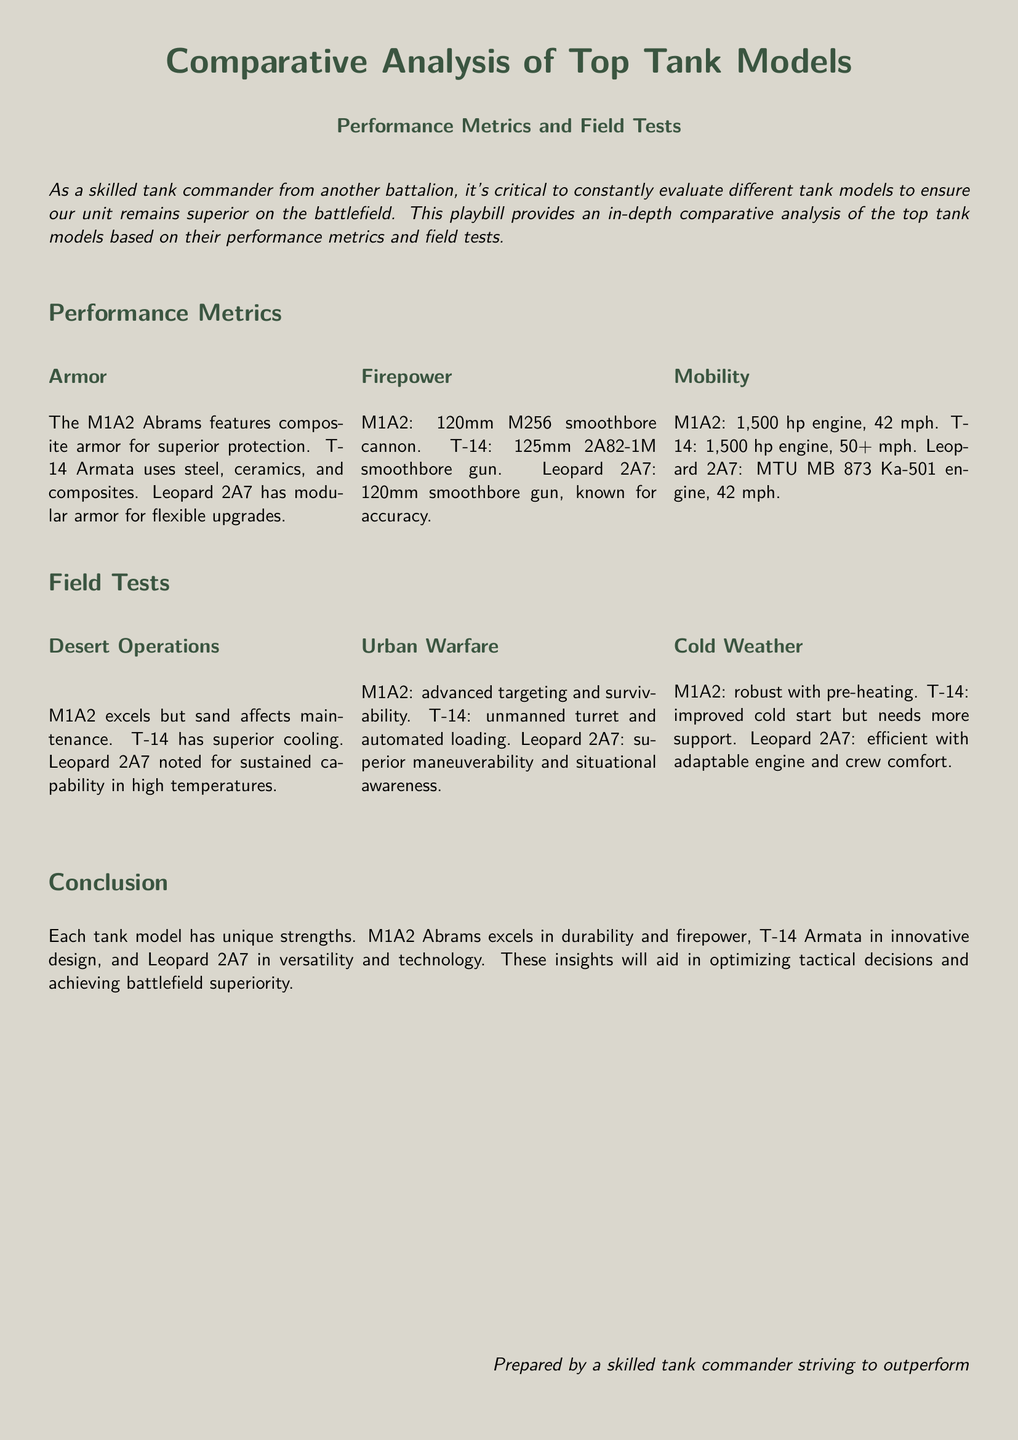What type of armor does the M1A2 Abrams feature? The document states that the M1A2 Abrams features composite armor for superior protection.
Answer: Composite armor What is the maximum speed of the T-14 Armata? According to the document, the T-14 Armata has a speed of 50+ mph.
Answer: 50+ mph Which tank model is noted for superior maneuverability in urban warfare? The Leopard 2A7 is mentioned in the document for its superior maneuverability and situational awareness in urban warfare.
Answer: Leopard 2A7 What weapon caliber does the Leopard 2A7 use? The document states that the Leopard 2A7 uses a 120mm smoothbore gun.
Answer: 120mm Which tank is recognized for its advanced targeting in urban warfare? The M1A2 is recognized in the document for its advanced targeting and survivability in urban warfare.
Answer: M1A2 What performance area does the T-14 Armata excel in during field tests? The T-14 Armata excels in cooling during desert operations as noted in the document.
Answer: Cooling How is the M1A2 Abrams described in terms of cold weather performance? The document describes the M1A2 Abrams as robust with pre-heating for cold weather performance.
Answer: Robust with pre-heating Who prepared the document? The document is prepared by a skilled tank commander striving to outperform.
Answer: A skilled tank commander 